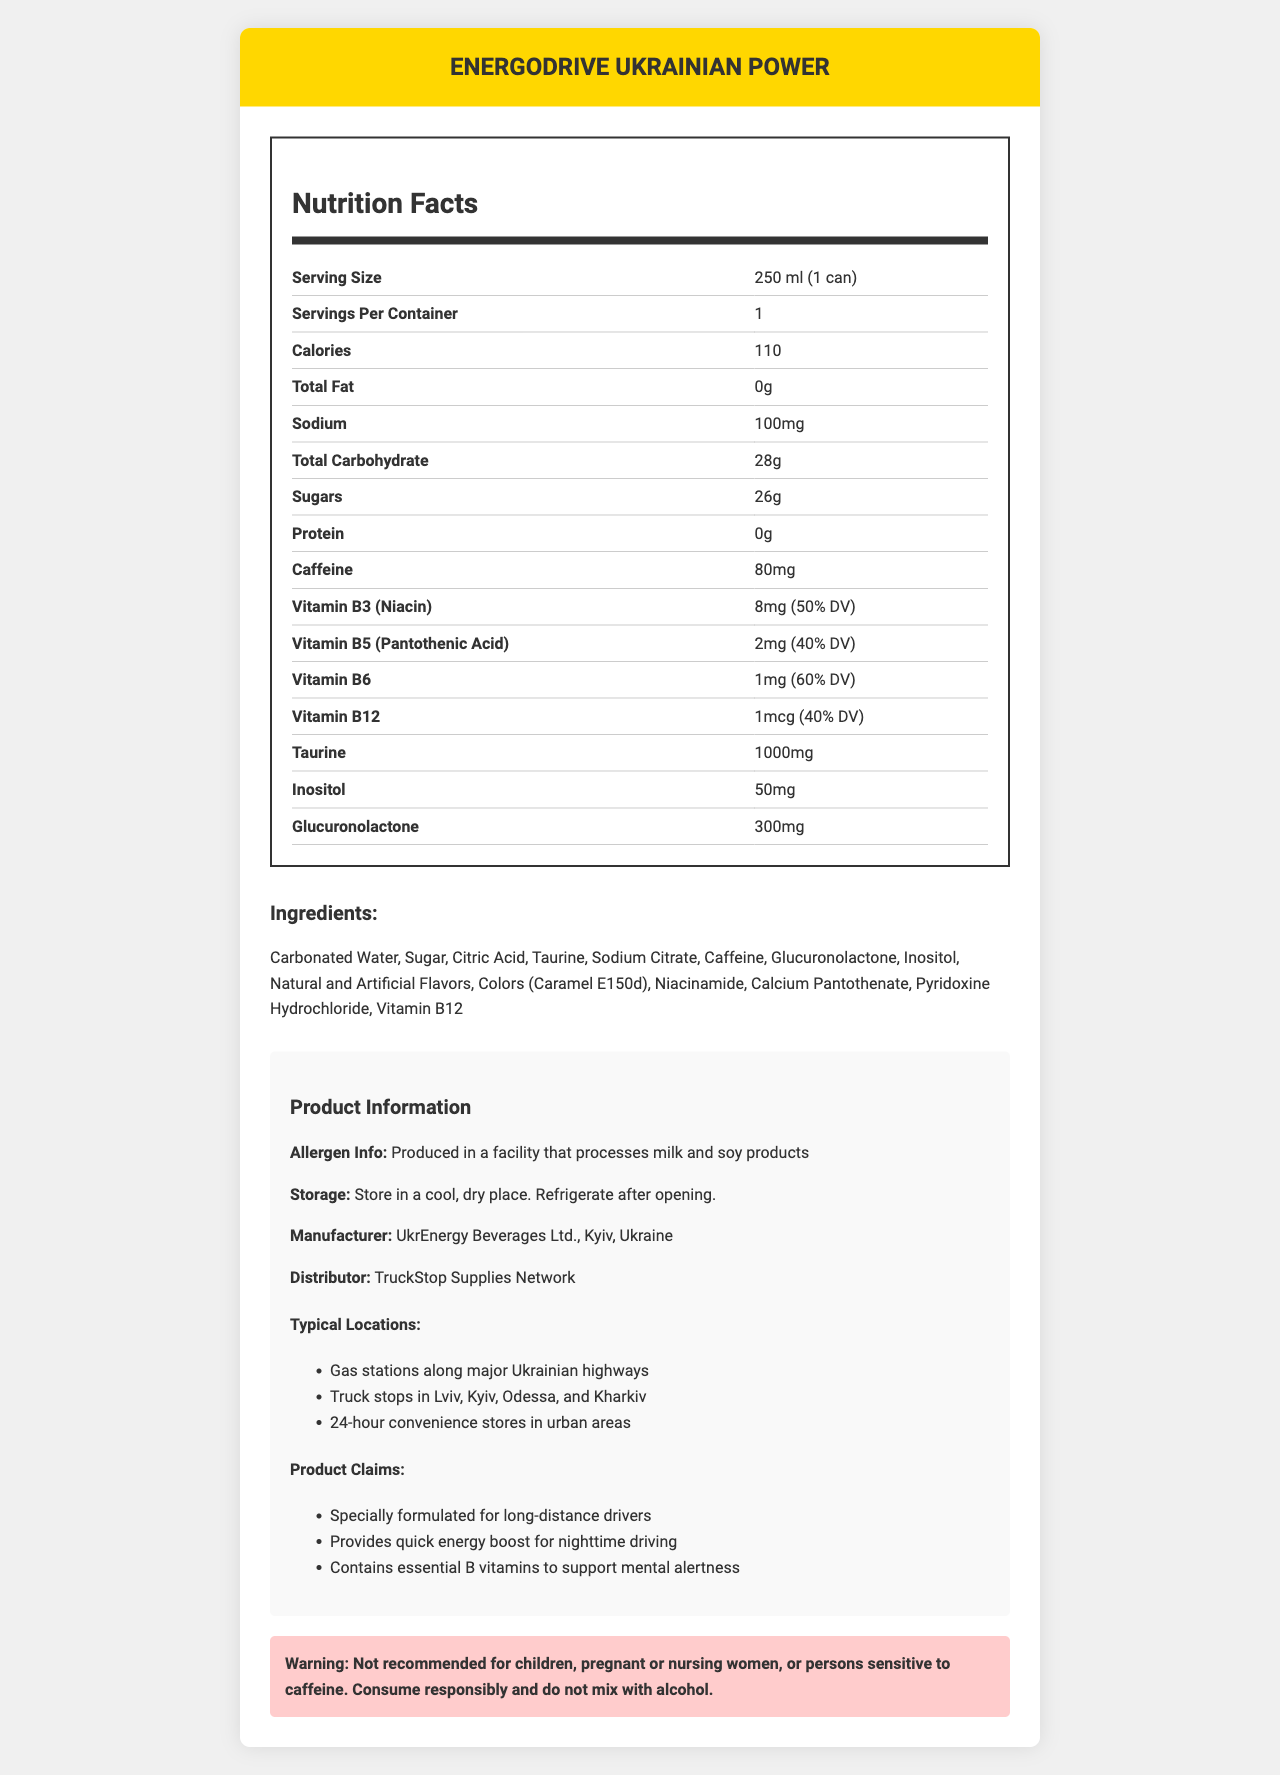how much caffeine is in one can of EnergoDrive Ukrainian Power? The nutrition label shows the caffeine content as 80mg per serving size, which is 1 can.
Answer: 80mg what vitamins are included in EnergoDrive Ukrainian Power? The nutrition label lists these specific vitamins and their respective daily value percentages.
Answer: Vitamins B3 (niacin), B5 (pantothenic acid), B6, and B12 how many calories are in one serving? The nutrition label clearly states 110 calories per serving size, which is 1 can.
Answer: 110 calories what is the serving size specified on the nutrition label? The serving size on the nutrition label is indicated as 250 ml (1 can).
Answer: 250 ml (1 can) what should you do after opening the can? The storage instructions mentioned in the document advise to refrigerate after opening.
Answer: Refrigerate after opening what is the main manufacturer of EnergoDrive Ukrainian Power? A. TruckStop Supplies Network B. UkrEnergy Beverages Ltd. C. Kyiv Manufacturing Co. D. Odessa Energy Drinks The document specifies UkrEnergy Beverages Ltd., Kyiv, Ukraine as the manufacturer.
Answer: B. UkrEnergy Beverages Ltd. what is the daily value percentage of vitamin B6 provided by EnergoDrive Ukrainian Power? A. 40% B. 50% C. 60% D. 70% The label displays that Vitamin B6 contributes 60% of the daily value (DV).
Answer: C. 60% is the product recommended for children or pregnant women? The warning section advises that the product is not recommended for children, pregnant or nursing women, or persons sensitive to caffeine.
Answer: No summarize the main information provided by the nutrition label and the product document. The document elaborates on the composition, nutritional value, and vitamins of EnergoDrive Ukrainian Power, along with its manufacturers, typical locations, product claims, storage instructions, and warnings.
Answer: EnergoDrive Ukrainian Power is an energy drink engineered for long-distance drivers, containing 80mg of caffeine and several essential B vitamins (B3, B5, B6, and B12). With 110 calories per can, the drink also includes ingredients like taurine, inositol, and glucuronolactone. It is manufactured by UkrEnergy Beverages Ltd. and distributed by TruckStop Supplies Network. Warnings are provided for children, pregnant women, and those sensitive to caffeine. what is the primary ingredient in EnergoDrive Ukrainian Power? The first ingredient listed in the ingredients section is Carbonated Water.
Answer: Carbonated Water can this product be mixed with alcohol? The warning section explicitly mentions not to mix the product with alcohol.
Answer: No what is the flavoring used in EnergoDrive Ukrainian Power? The ingredients section lists Natural and Artificial Flavors as components.
Answer: Natural and Artificial Flavors where can you typically find EnergoDrive Ukrainian Power? The document specifies these locations as typical places to find the product.
Answer: Gas stations along major Ukrainian highways, truck stops in Lviv, Kyiv, Odessa, and Kharkiv, and 24-hour convenience stores in urban areas what are the claims made by the manufacturer about EnergoDrive Ukrainian Power? These claims are listed in the product claims section of the document.
Answer: Specially formulated for long-distance drivers, provides quick energy boost for nighttime driving, contains essential B vitamins to support mental alertness how many grams of sugar does EnergoDrive Ukrainian Power contain per can? The nutrition label indicates that each can contains 26 grams of sugar.
Answer: 26g who distributes EnergoDrive Ukrainian Power? The document lists TruckStop Supplies Network as the distributor of the product.
Answer: TruckStop Supplies Network what is the purpose of glucuronolactone in EnergoDrive Ukrainian Power? The document does not provide specific information regarding the purpose of glucuronolactone in the product.
Answer: Not enough information 